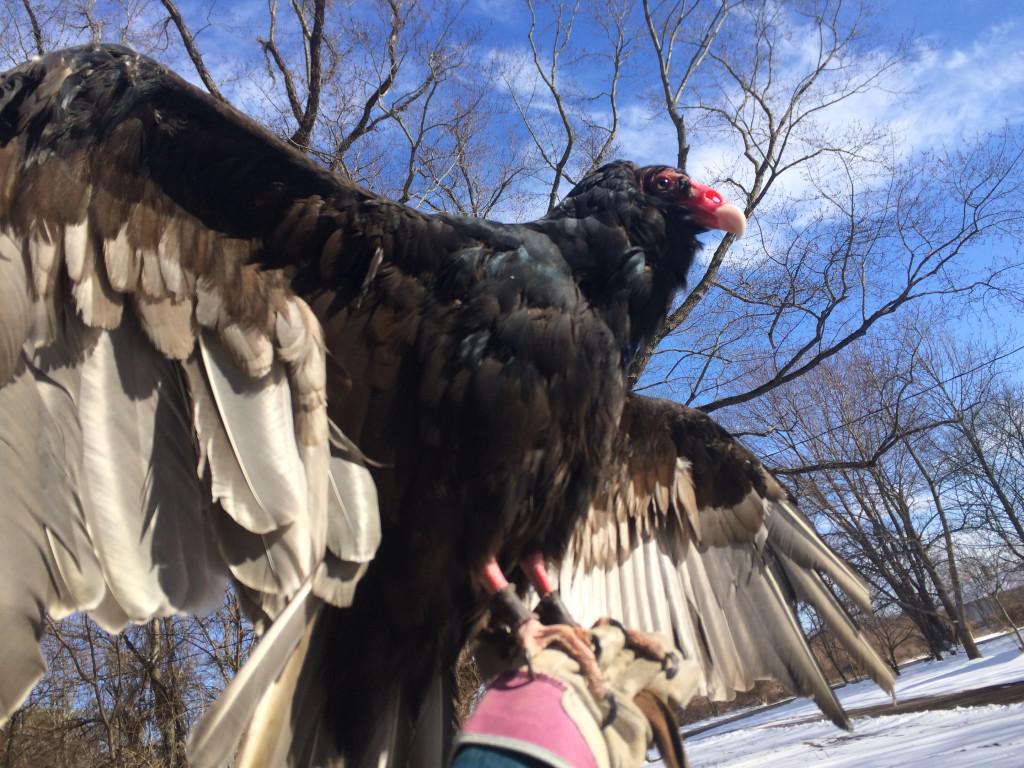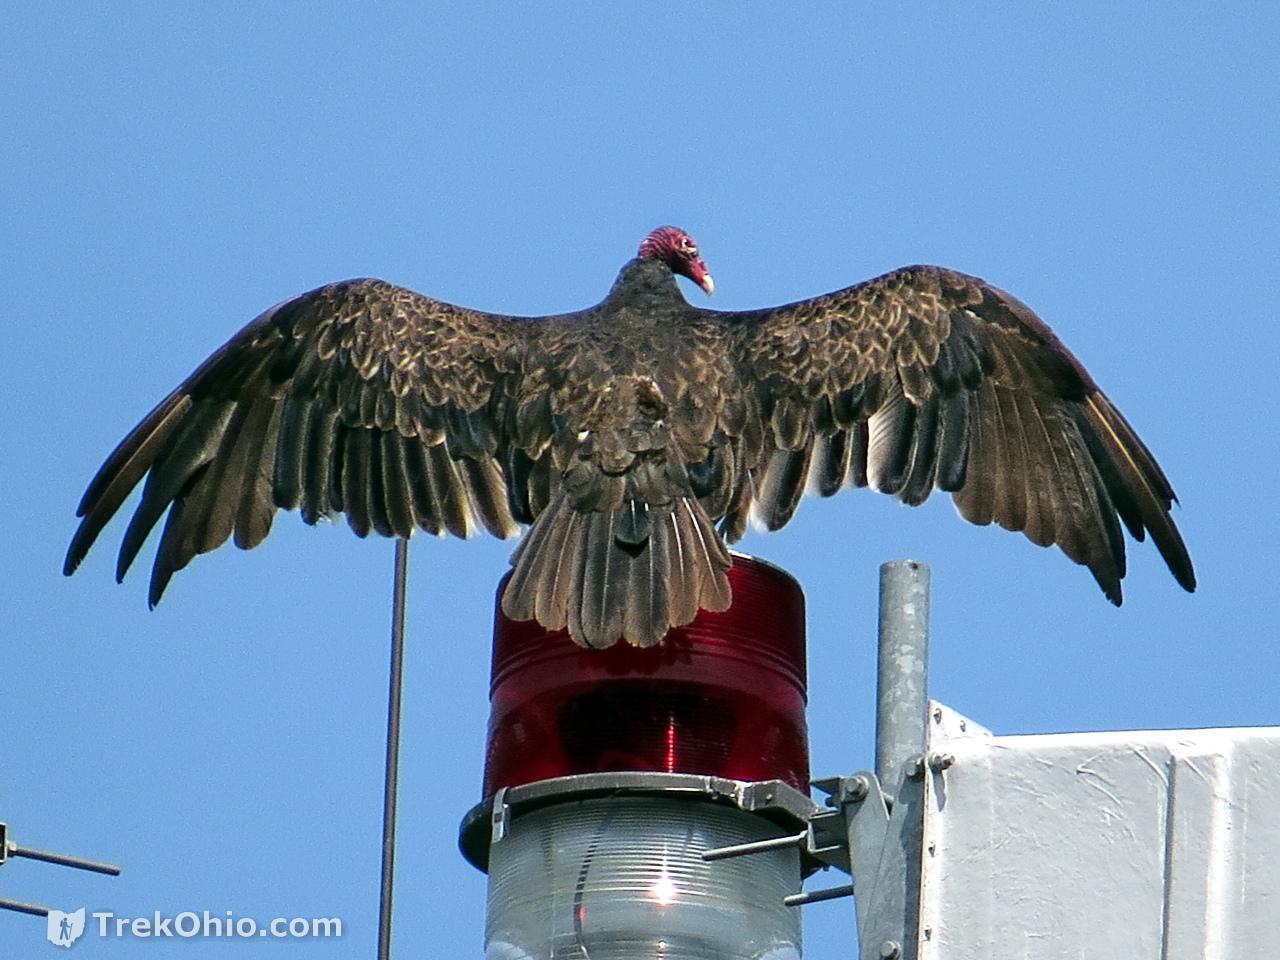The first image is the image on the left, the second image is the image on the right. Given the left and right images, does the statement "The left and right image contains a total of two vultures facing different directions." hold true? Answer yes or no. Yes. The first image is the image on the left, the second image is the image on the right. Evaluate the accuracy of this statement regarding the images: "The left image contains one vulture perched on a leafless branch, with its wings tucked.". Is it true? Answer yes or no. No. 